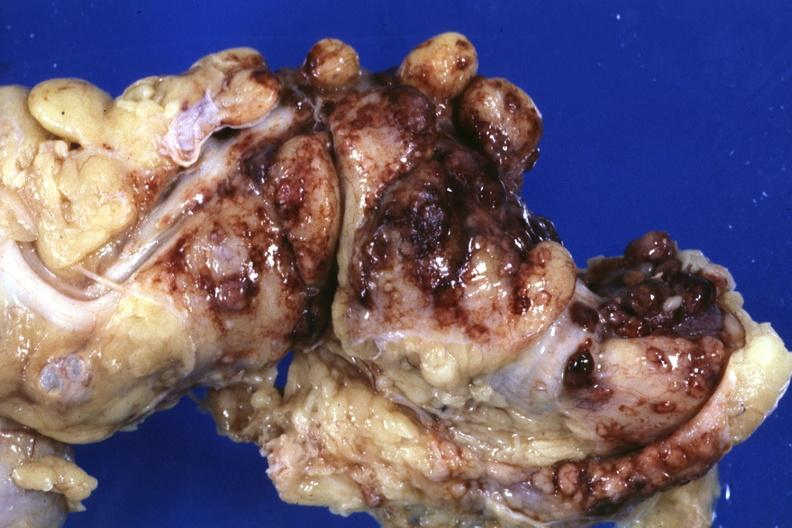does abdomen show fixed tissue?
Answer the question using a single word or phrase. No 